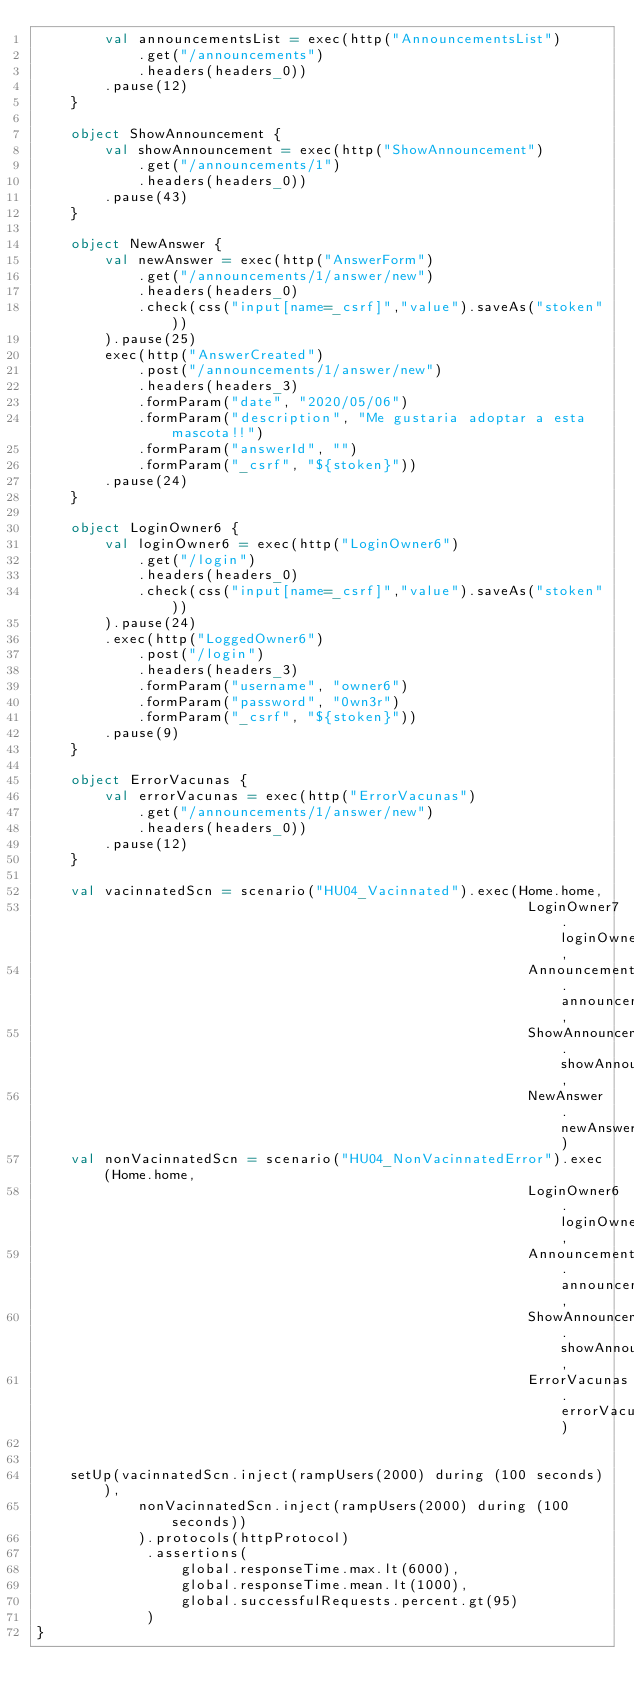<code> <loc_0><loc_0><loc_500><loc_500><_Scala_>		val announcementsList = exec(http("AnnouncementsList")
			.get("/announcements")
			.headers(headers_0))
		.pause(12)
	}

	object ShowAnnouncement {
		val showAnnouncement = exec(http("ShowAnnouncement")
			.get("/announcements/1")
			.headers(headers_0))
		.pause(43)
	}

	object NewAnswer {
		val newAnswer = exec(http("AnswerForm")
			.get("/announcements/1/answer/new")
			.headers(headers_0)
			.check(css("input[name=_csrf]","value").saveAs("stoken"))
		).pause(25)
		exec(http("AnswerCreated")
			.post("/announcements/1/answer/new")
			.headers(headers_3)
			.formParam("date", "2020/05/06")
			.formParam("description", "Me gustaria adoptar a esta mascota!!")
			.formParam("answerId", "")
			.formParam("_csrf", "${stoken}"))
		.pause(24)
	}

	object LoginOwner6 {
		val loginOwner6 = exec(http("LoginOwner6")
			.get("/login")
			.headers(headers_0)
			.check(css("input[name=_csrf]","value").saveAs("stoken"))
		).pause(24)
		.exec(http("LoggedOwner6")
			.post("/login")
			.headers(headers_3)
			.formParam("username", "owner6")
			.formParam("password", "0wn3r")
			.formParam("_csrf", "${stoken}"))
		.pause(9)
	}

	object ErrorVacunas {
		val errorVacunas = exec(http("ErrorVacunas")
			.get("/announcements/1/answer/new")
			.headers(headers_0))
		.pause(12)
	}

	val vacinnatedScn = scenario("HU04_Vacinnated").exec(Home.home,
														  LoginOwner7.loginOwner7,
														  AnnouncementsList.announcementsList,
														  ShowAnnouncement.showAnnouncement,
														  NewAnswer.newAnswer)
	val nonVacinnatedScn = scenario("HU04_NonVacinnatedError").exec(Home.home,
														  LoginOwner6.loginOwner6,
														  AnnouncementsList.announcementsList,
														  ShowAnnouncement.showAnnouncement,
														  ErrorVacunas.errorVacunas)
		

	setUp(vacinnatedScn.inject(rampUsers(2000) during (100 seconds)),
            nonVacinnatedScn.inject(rampUsers(2000) during (100 seconds))
            ).protocols(httpProtocol)
			 .assertions(
                 global.responseTime.max.lt(6000),
                 global.responseTime.mean.lt(1000),
                 global.successfulRequests.percent.gt(95)
             )
}</code> 